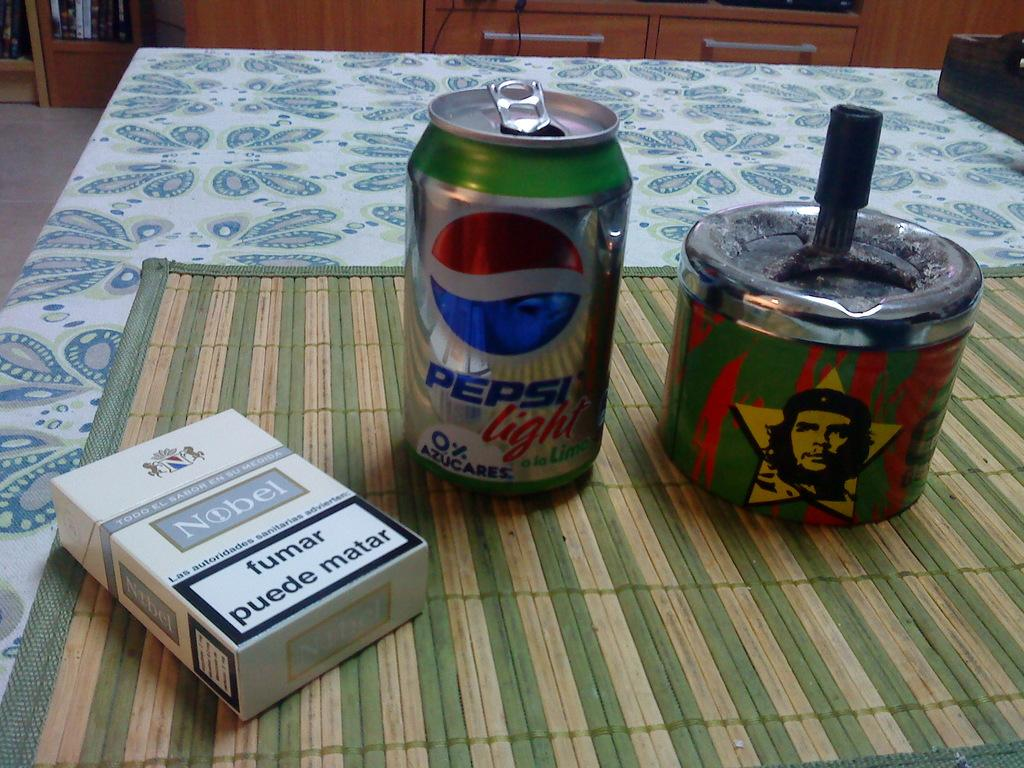<image>
Render a clear and concise summary of the photo. A pack of cigaretes, can of Pepsi and a can for donations with a picture Che Guevara on it. 